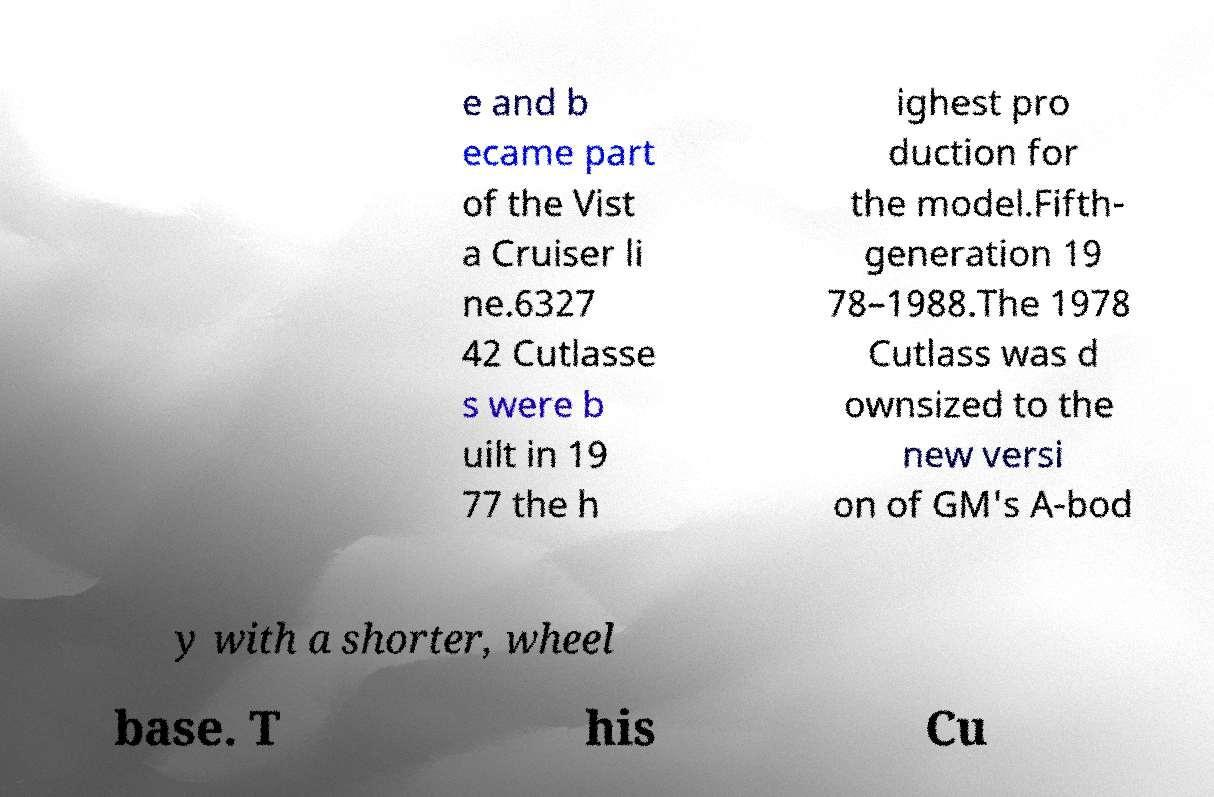Can you accurately transcribe the text from the provided image for me? e and b ecame part of the Vist a Cruiser li ne.6327 42 Cutlasse s were b uilt in 19 77 the h ighest pro duction for the model.Fifth- generation 19 78–1988.The 1978 Cutlass was d ownsized to the new versi on of GM's A-bod y with a shorter, wheel base. T his Cu 